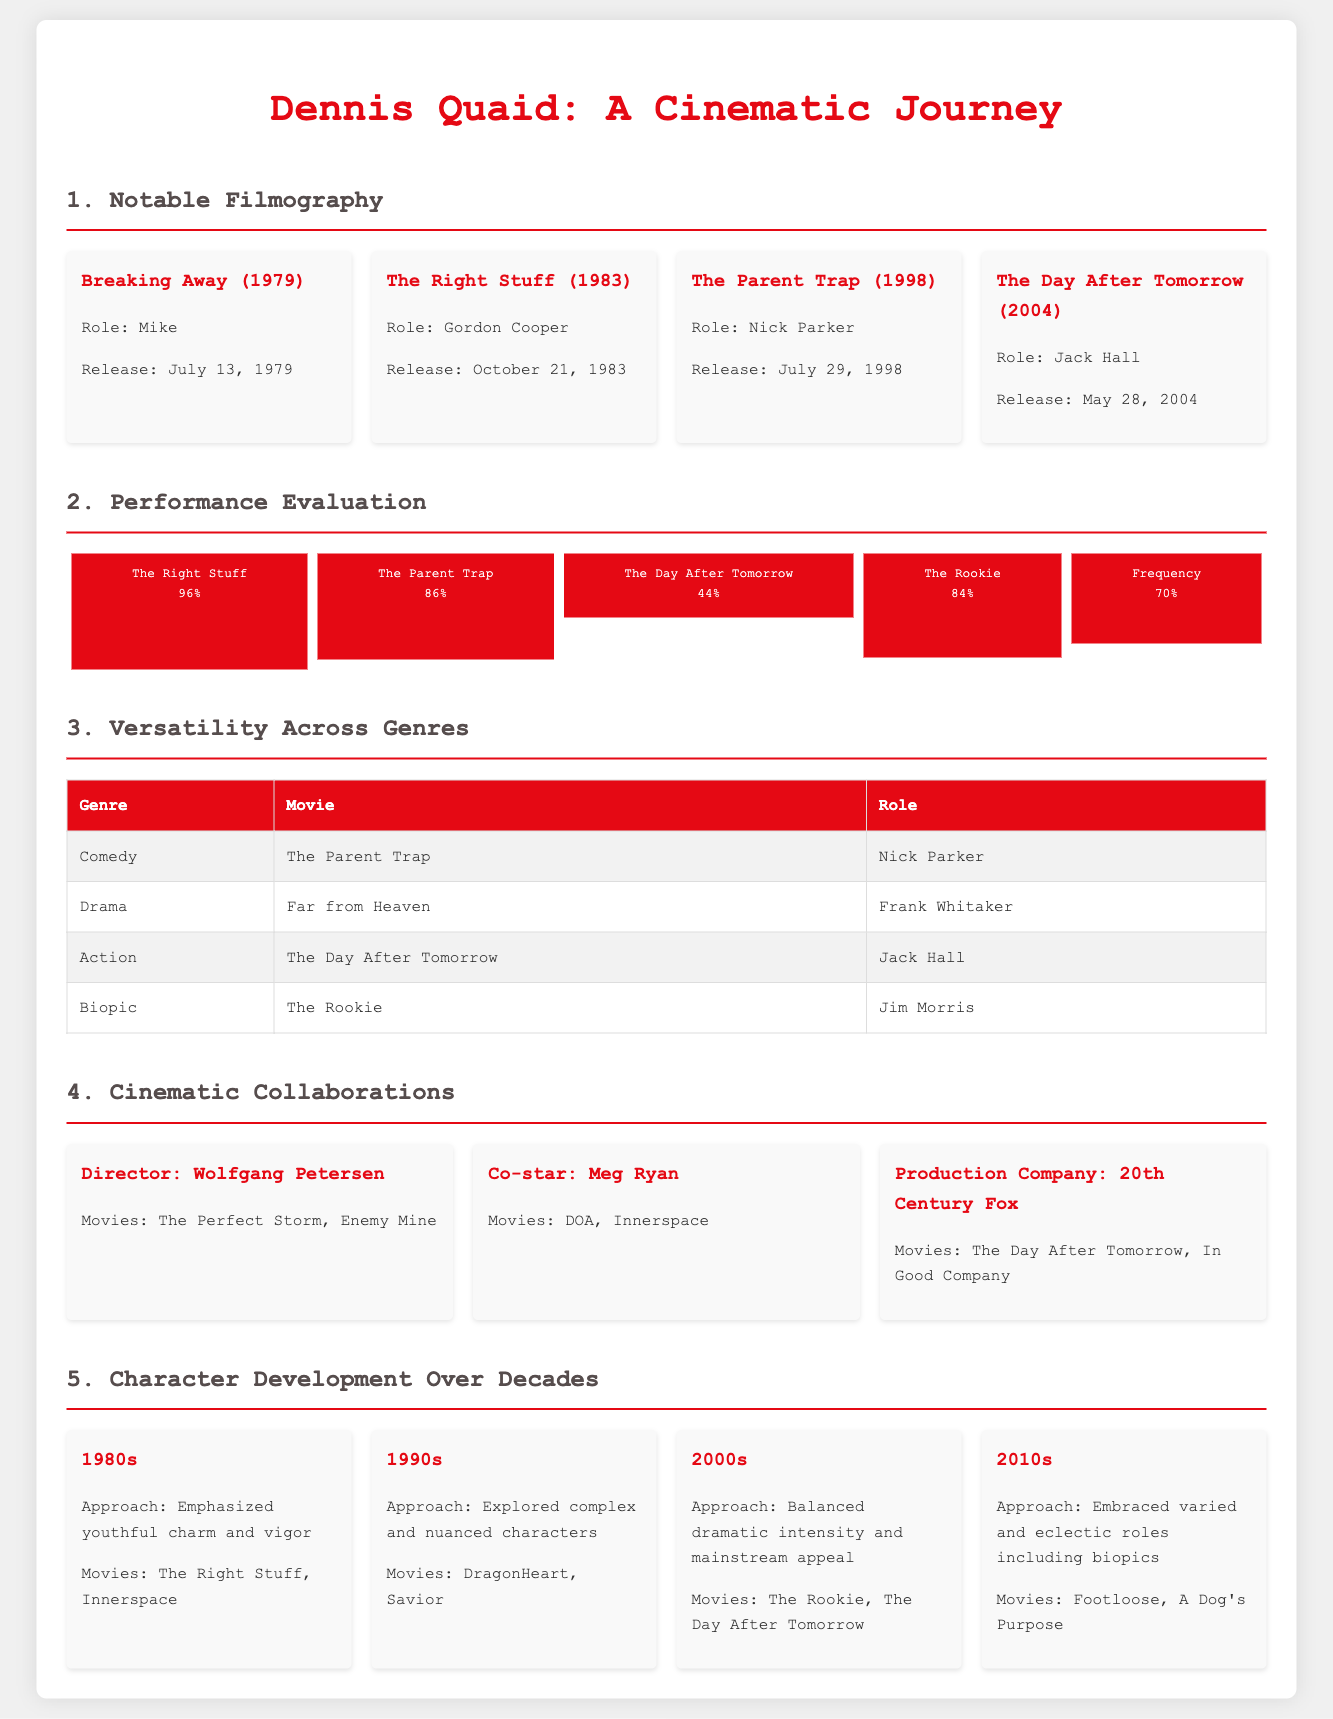what role did Dennis Quaid play in Breaking Away? The document states that he played the role of Mike in Breaking Away.
Answer: Mike when was The Right Stuff released? The release date for The Right Stuff is provided in the document as October 21, 1983.
Answer: October 21, 1983 what is the Rotten Tomatoes score for The Rookie? The performance evaluation section lists the score for The Rookie as 84%.
Answer: 84% which genre does the movie The Parent Trap belong to? The table in the document indicates that The Parent Trap is under the comedy genre.
Answer: Comedy who directed The Perfect Storm? The document mentions Wolfgang Petersen as the director of The Perfect Storm.
Answer: Wolfgang Petersen which decade featured characters with “youthful charm and vigor”? The character development section states that this approach was taken in the 1980s.
Answer: 1980s how many movies are listed in the Cinematic Collaborations section? The document lists three entities in the Cinematic Collaborations section.
Answer: Three what percentage did The Day After Tomorrow receive on Rotten Tomatoes? The performance chart specifies that The Day After Tomorrow received a score of 44%.
Answer: 44% 